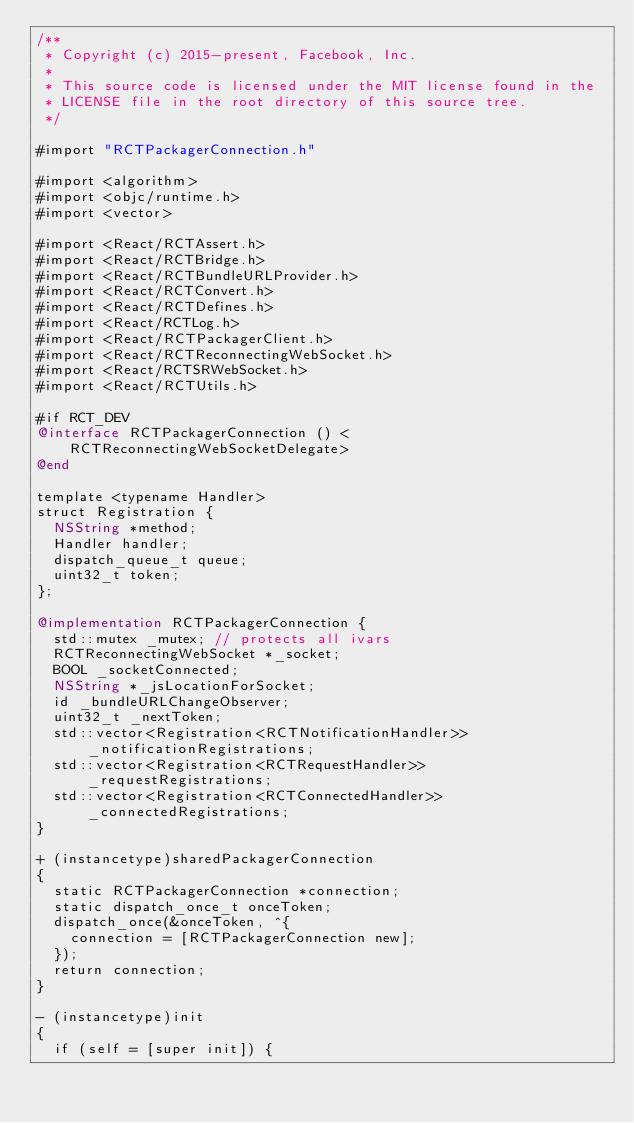Convert code to text. <code><loc_0><loc_0><loc_500><loc_500><_ObjectiveC_>/**
 * Copyright (c) 2015-present, Facebook, Inc.
 *
 * This source code is licensed under the MIT license found in the
 * LICENSE file in the root directory of this source tree.
 */

#import "RCTPackagerConnection.h"

#import <algorithm>
#import <objc/runtime.h>
#import <vector>

#import <React/RCTAssert.h>
#import <React/RCTBridge.h>
#import <React/RCTBundleURLProvider.h>
#import <React/RCTConvert.h>
#import <React/RCTDefines.h>
#import <React/RCTLog.h>
#import <React/RCTPackagerClient.h>
#import <React/RCTReconnectingWebSocket.h>
#import <React/RCTSRWebSocket.h>
#import <React/RCTUtils.h>

#if RCT_DEV
@interface RCTPackagerConnection () <RCTReconnectingWebSocketDelegate>
@end

template <typename Handler>
struct Registration {
  NSString *method;
  Handler handler;
  dispatch_queue_t queue;
  uint32_t token;
};

@implementation RCTPackagerConnection {
  std::mutex _mutex; // protects all ivars
  RCTReconnectingWebSocket *_socket;
  BOOL _socketConnected;
  NSString *_jsLocationForSocket;
  id _bundleURLChangeObserver;
  uint32_t _nextToken;
  std::vector<Registration<RCTNotificationHandler>> _notificationRegistrations;
  std::vector<Registration<RCTRequestHandler>> _requestRegistrations;
  std::vector<Registration<RCTConnectedHandler>> _connectedRegistrations;
}

+ (instancetype)sharedPackagerConnection
{
  static RCTPackagerConnection *connection;
  static dispatch_once_t onceToken;
  dispatch_once(&onceToken, ^{
    connection = [RCTPackagerConnection new];
  });
  return connection;
}

- (instancetype)init
{
  if (self = [super init]) {</code> 